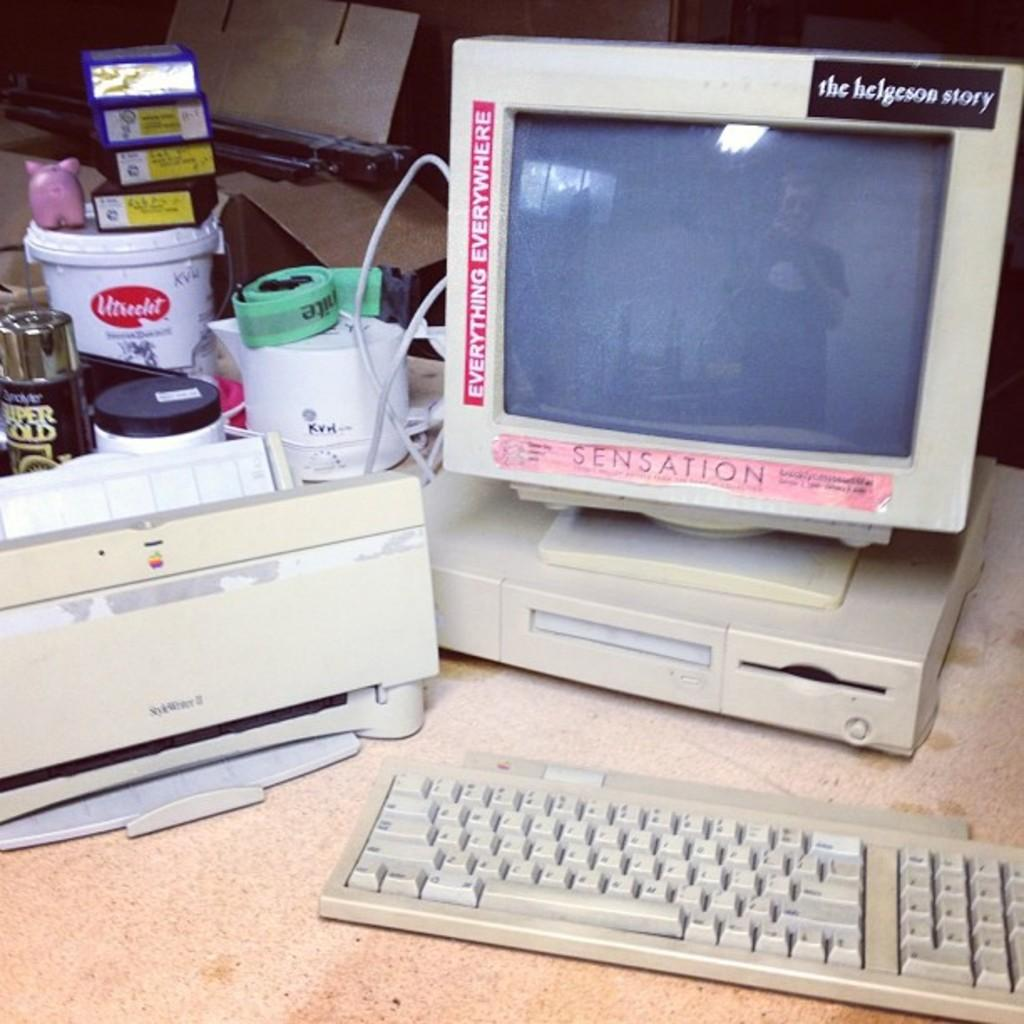<image>
Offer a succinct explanation of the picture presented. Old computer with a red sticker that says "EVERYTHING EVERYWHERE". 